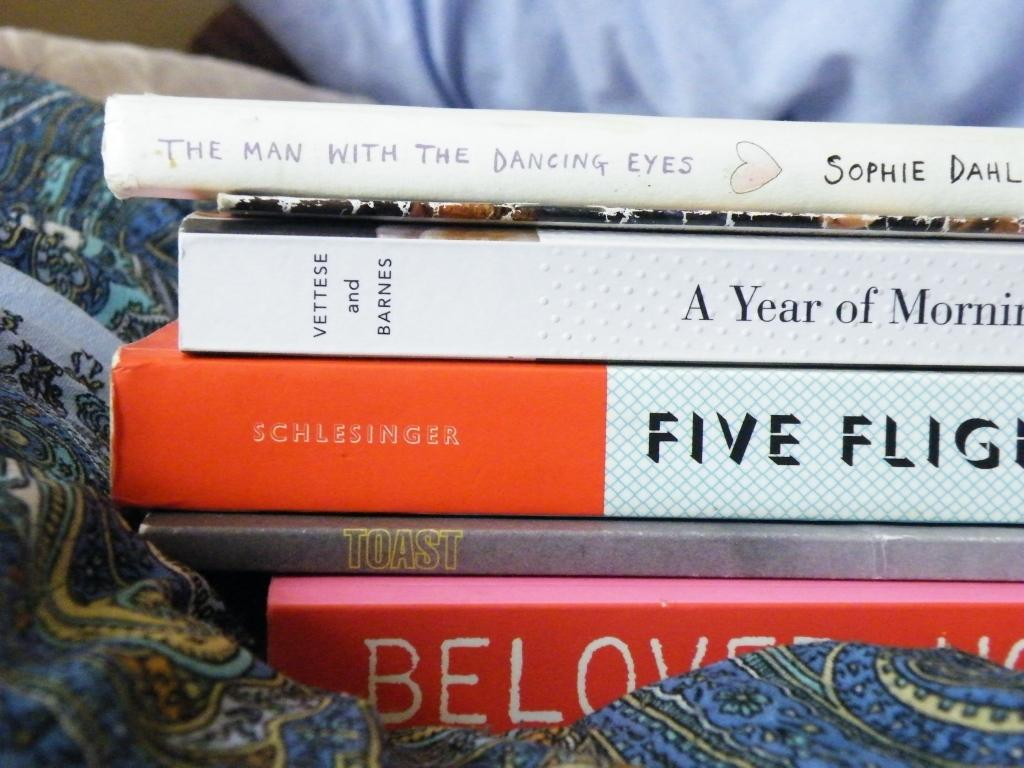<image>
Present a compact description of the photo's key features. Five books stacked on top of each other, the top one says The Man with Dancing Eyes. 